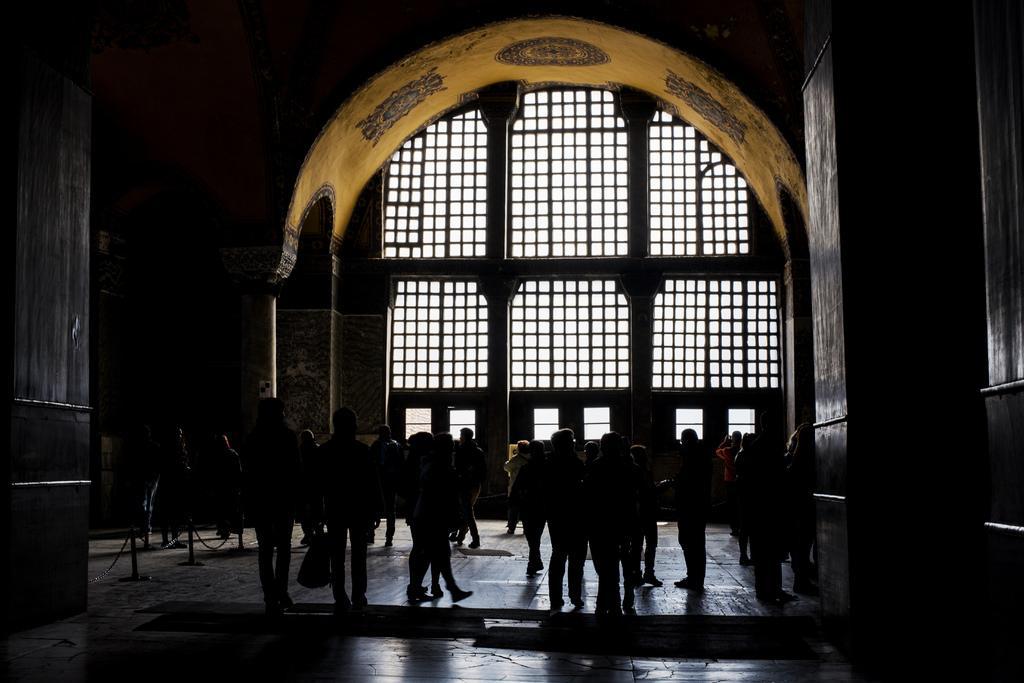In one or two sentences, can you explain what this image depicts? In this image I can see group of people standing, background I can see the arch and I can also see the railing. The sky is in white color. 